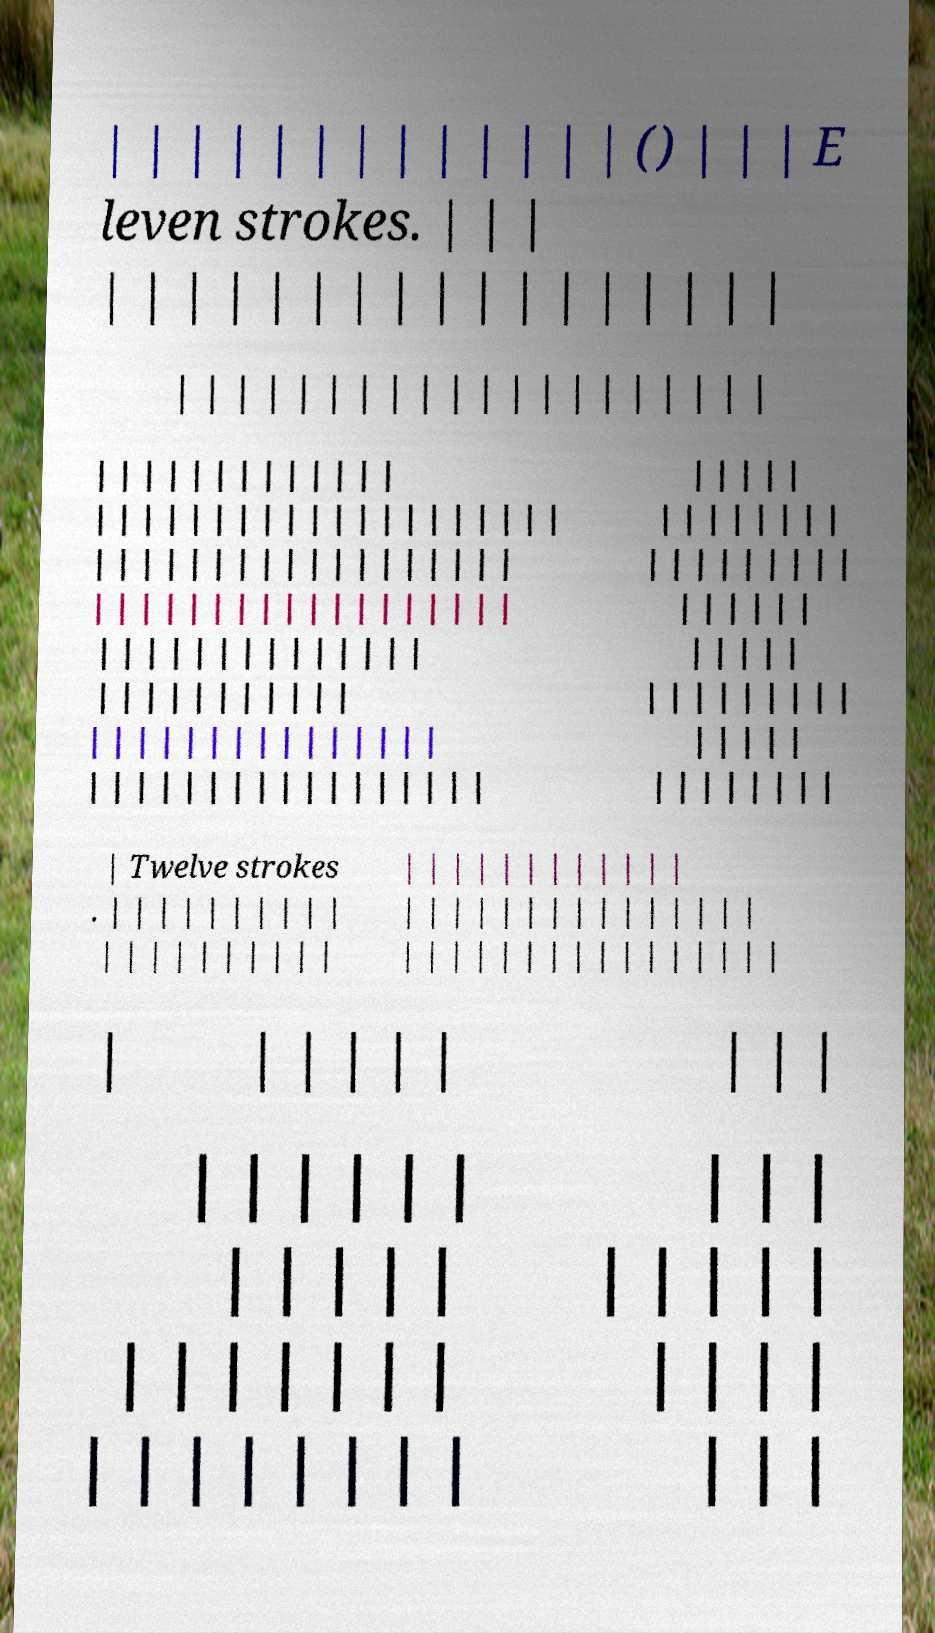Could you assist in decoding the text presented in this image and type it out clearly? | | | | | | | | | | | | | () | | | E leven strokes. | | | | | | | | | | | | | | | | | | | | | | | | | | | | | | | | | | | | | | | | | | | | | | | | | | | | | | | | | | | | | | | | | | | | | | | | | | | | | | | | | | | | | | | | | | | | | | | | | | | | | | | | | | | | | | | | | | | | | | | | | | | | | | | | | | | | | | | | | | | | | | | | | | | | | | | | | | | | | | | | | | | | | | | | | | | | | | | | | | | | | | | | | | | | | | | | | | | | | | | | | | | | | | | | | | | | | | | | | | | | | | Twelve strokes . | | | | | | | | | | | | | | | | | | | | | | | | | | | | | | | | | | | | | | | | | | | | | | | | | | | | | | | | | | | | | | | | | | | | | | | | | | | | | | | | | | | | | | | | | | | | | | | | | | | | | | | | | | | | | | | | | 